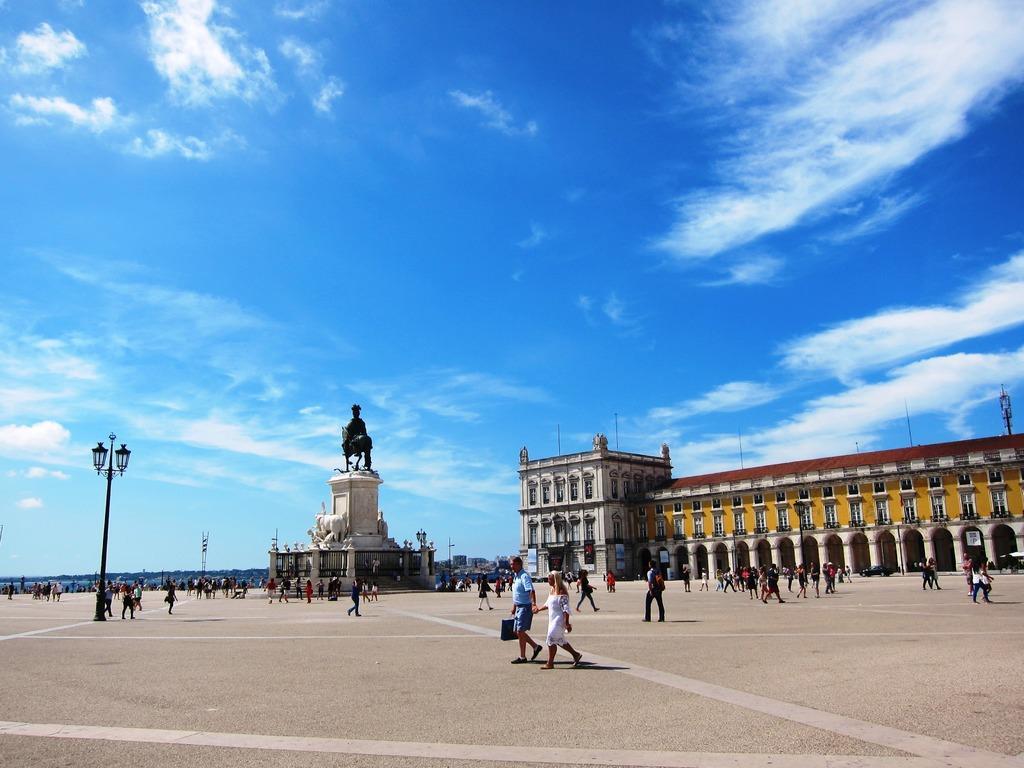Can you describe this image briefly? In this image I can see the group of people with different color dresses. To the left I can see the pole with lights. In the background I can see the statue of the person and the building. I can also see the clouds and the blue sky. 